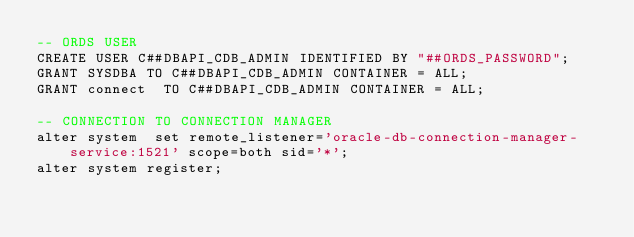Convert code to text. <code><loc_0><loc_0><loc_500><loc_500><_SQL_>-- ORDS USER
CREATE USER C##DBAPI_CDB_ADMIN IDENTIFIED BY "##ORDS_PASSWORD";
GRANT SYSDBA TO C##DBAPI_CDB_ADMIN CONTAINER = ALL;
GRANT connect  TO C##DBAPI_CDB_ADMIN CONTAINER = ALL;

-- CONNECTION TO CONNECTION MANAGER
alter system  set remote_listener='oracle-db-connection-manager-service:1521' scope=both sid='*';
alter system register;

</code> 